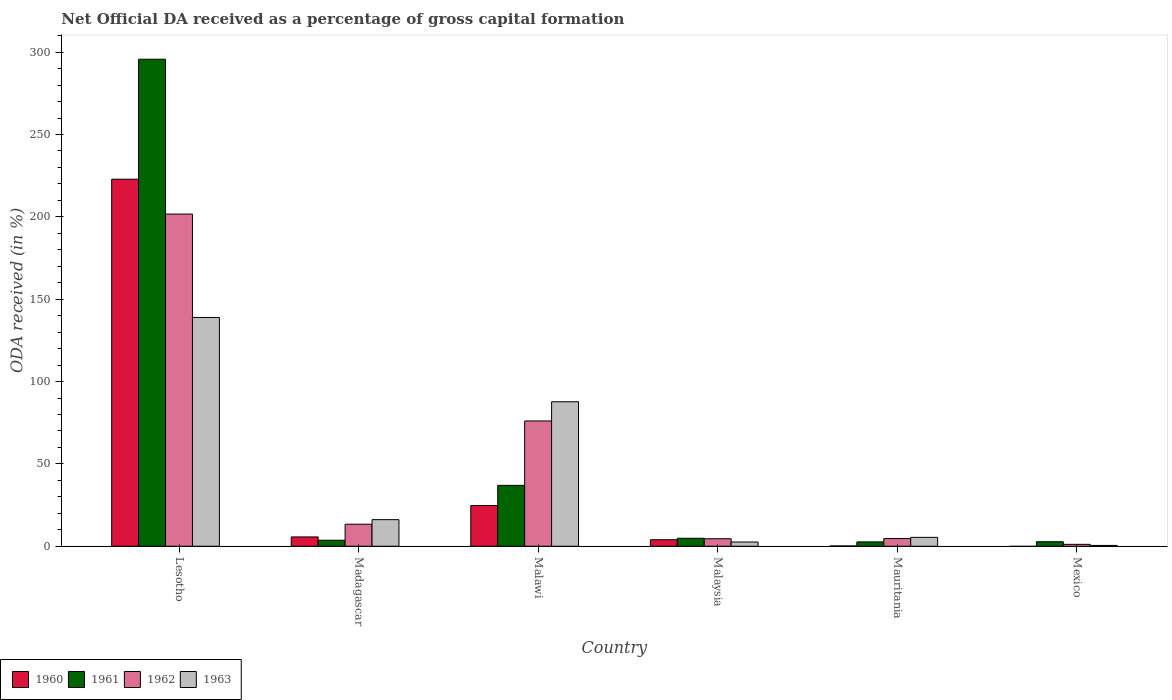How many different coloured bars are there?
Make the answer very short. 4. Are the number of bars per tick equal to the number of legend labels?
Give a very brief answer. No. What is the label of the 3rd group of bars from the left?
Your response must be concise. Malawi. In how many cases, is the number of bars for a given country not equal to the number of legend labels?
Provide a succinct answer. 1. What is the net ODA received in 1961 in Mexico?
Your answer should be very brief. 2.74. Across all countries, what is the maximum net ODA received in 1963?
Your answer should be very brief. 138.92. Across all countries, what is the minimum net ODA received in 1960?
Ensure brevity in your answer.  0. In which country was the net ODA received in 1961 maximum?
Give a very brief answer. Lesotho. What is the total net ODA received in 1962 in the graph?
Give a very brief answer. 301.54. What is the difference between the net ODA received in 1962 in Lesotho and that in Madagascar?
Your answer should be very brief. 188.32. What is the difference between the net ODA received in 1963 in Malawi and the net ODA received in 1960 in Lesotho?
Give a very brief answer. -135.12. What is the average net ODA received in 1962 per country?
Keep it short and to the point. 50.26. What is the difference between the net ODA received of/in 1963 and net ODA received of/in 1961 in Malawi?
Make the answer very short. 50.77. In how many countries, is the net ODA received in 1963 greater than 110 %?
Your answer should be compact. 1. What is the ratio of the net ODA received in 1963 in Mauritania to that in Mexico?
Provide a short and direct response. 10.77. Is the net ODA received in 1961 in Madagascar less than that in Mexico?
Provide a succinct answer. No. Is the difference between the net ODA received in 1963 in Madagascar and Mexico greater than the difference between the net ODA received in 1961 in Madagascar and Mexico?
Your answer should be very brief. Yes. What is the difference between the highest and the second highest net ODA received in 1961?
Your answer should be very brief. 32.13. What is the difference between the highest and the lowest net ODA received in 1963?
Keep it short and to the point. 138.41. Is it the case that in every country, the sum of the net ODA received in 1960 and net ODA received in 1961 is greater than the sum of net ODA received in 1963 and net ODA received in 1962?
Make the answer very short. No. Are all the bars in the graph horizontal?
Make the answer very short. No. What is the difference between two consecutive major ticks on the Y-axis?
Provide a succinct answer. 50. Does the graph contain any zero values?
Make the answer very short. Yes. Where does the legend appear in the graph?
Make the answer very short. Bottom left. How are the legend labels stacked?
Provide a succinct answer. Horizontal. What is the title of the graph?
Give a very brief answer. Net Official DA received as a percentage of gross capital formation. What is the label or title of the X-axis?
Your answer should be very brief. Country. What is the label or title of the Y-axis?
Make the answer very short. ODA received (in %). What is the ODA received (in %) of 1960 in Lesotho?
Ensure brevity in your answer.  222.86. What is the ODA received (in %) in 1961 in Lesotho?
Offer a very short reply. 295.71. What is the ODA received (in %) of 1962 in Lesotho?
Your answer should be very brief. 201.7. What is the ODA received (in %) of 1963 in Lesotho?
Offer a terse response. 138.92. What is the ODA received (in %) of 1960 in Madagascar?
Give a very brief answer. 5.66. What is the ODA received (in %) in 1961 in Madagascar?
Make the answer very short. 3.65. What is the ODA received (in %) of 1962 in Madagascar?
Your response must be concise. 13.38. What is the ODA received (in %) in 1963 in Madagascar?
Your response must be concise. 16.15. What is the ODA received (in %) of 1960 in Malawi?
Provide a short and direct response. 24.76. What is the ODA received (in %) of 1961 in Malawi?
Make the answer very short. 36.97. What is the ODA received (in %) of 1962 in Malawi?
Provide a short and direct response. 76.08. What is the ODA received (in %) of 1963 in Malawi?
Provide a short and direct response. 87.74. What is the ODA received (in %) in 1960 in Malaysia?
Keep it short and to the point. 3.95. What is the ODA received (in %) of 1961 in Malaysia?
Offer a terse response. 4.84. What is the ODA received (in %) of 1962 in Malaysia?
Make the answer very short. 4.56. What is the ODA received (in %) in 1963 in Malaysia?
Provide a short and direct response. 2.57. What is the ODA received (in %) of 1960 in Mauritania?
Your response must be concise. 0.19. What is the ODA received (in %) of 1961 in Mauritania?
Offer a very short reply. 2.65. What is the ODA received (in %) of 1962 in Mauritania?
Ensure brevity in your answer.  4.66. What is the ODA received (in %) of 1963 in Mauritania?
Keep it short and to the point. 5.4. What is the ODA received (in %) in 1961 in Mexico?
Keep it short and to the point. 2.74. What is the ODA received (in %) of 1962 in Mexico?
Give a very brief answer. 1.16. What is the ODA received (in %) of 1963 in Mexico?
Keep it short and to the point. 0.5. Across all countries, what is the maximum ODA received (in %) of 1960?
Your answer should be compact. 222.86. Across all countries, what is the maximum ODA received (in %) in 1961?
Offer a very short reply. 295.71. Across all countries, what is the maximum ODA received (in %) of 1962?
Offer a very short reply. 201.7. Across all countries, what is the maximum ODA received (in %) of 1963?
Your response must be concise. 138.92. Across all countries, what is the minimum ODA received (in %) of 1960?
Your response must be concise. 0. Across all countries, what is the minimum ODA received (in %) in 1961?
Make the answer very short. 2.65. Across all countries, what is the minimum ODA received (in %) in 1962?
Your response must be concise. 1.16. Across all countries, what is the minimum ODA received (in %) of 1963?
Keep it short and to the point. 0.5. What is the total ODA received (in %) in 1960 in the graph?
Make the answer very short. 257.42. What is the total ODA received (in %) in 1961 in the graph?
Ensure brevity in your answer.  346.57. What is the total ODA received (in %) of 1962 in the graph?
Keep it short and to the point. 301.54. What is the total ODA received (in %) in 1963 in the graph?
Provide a succinct answer. 251.28. What is the difference between the ODA received (in %) of 1960 in Lesotho and that in Madagascar?
Provide a succinct answer. 217.2. What is the difference between the ODA received (in %) in 1961 in Lesotho and that in Madagascar?
Provide a succinct answer. 292.06. What is the difference between the ODA received (in %) in 1962 in Lesotho and that in Madagascar?
Your response must be concise. 188.32. What is the difference between the ODA received (in %) of 1963 in Lesotho and that in Madagascar?
Your answer should be compact. 122.76. What is the difference between the ODA received (in %) of 1960 in Lesotho and that in Malawi?
Keep it short and to the point. 198.1. What is the difference between the ODA received (in %) of 1961 in Lesotho and that in Malawi?
Make the answer very short. 258.74. What is the difference between the ODA received (in %) in 1962 in Lesotho and that in Malawi?
Offer a very short reply. 125.62. What is the difference between the ODA received (in %) in 1963 in Lesotho and that in Malawi?
Provide a succinct answer. 51.18. What is the difference between the ODA received (in %) of 1960 in Lesotho and that in Malaysia?
Make the answer very short. 218.91. What is the difference between the ODA received (in %) in 1961 in Lesotho and that in Malaysia?
Offer a terse response. 290.87. What is the difference between the ODA received (in %) in 1962 in Lesotho and that in Malaysia?
Make the answer very short. 197.14. What is the difference between the ODA received (in %) in 1963 in Lesotho and that in Malaysia?
Ensure brevity in your answer.  136.35. What is the difference between the ODA received (in %) of 1960 in Lesotho and that in Mauritania?
Keep it short and to the point. 222.67. What is the difference between the ODA received (in %) of 1961 in Lesotho and that in Mauritania?
Keep it short and to the point. 293.07. What is the difference between the ODA received (in %) in 1962 in Lesotho and that in Mauritania?
Ensure brevity in your answer.  197.04. What is the difference between the ODA received (in %) of 1963 in Lesotho and that in Mauritania?
Offer a very short reply. 133.51. What is the difference between the ODA received (in %) of 1961 in Lesotho and that in Mexico?
Provide a short and direct response. 292.98. What is the difference between the ODA received (in %) of 1962 in Lesotho and that in Mexico?
Provide a succinct answer. 200.54. What is the difference between the ODA received (in %) of 1963 in Lesotho and that in Mexico?
Give a very brief answer. 138.41. What is the difference between the ODA received (in %) of 1960 in Madagascar and that in Malawi?
Ensure brevity in your answer.  -19.11. What is the difference between the ODA received (in %) in 1961 in Madagascar and that in Malawi?
Offer a very short reply. -33.32. What is the difference between the ODA received (in %) in 1962 in Madagascar and that in Malawi?
Your answer should be compact. -62.7. What is the difference between the ODA received (in %) in 1963 in Madagascar and that in Malawi?
Ensure brevity in your answer.  -71.59. What is the difference between the ODA received (in %) of 1960 in Madagascar and that in Malaysia?
Keep it short and to the point. 1.7. What is the difference between the ODA received (in %) in 1961 in Madagascar and that in Malaysia?
Keep it short and to the point. -1.19. What is the difference between the ODA received (in %) in 1962 in Madagascar and that in Malaysia?
Keep it short and to the point. 8.82. What is the difference between the ODA received (in %) of 1963 in Madagascar and that in Malaysia?
Your answer should be very brief. 13.59. What is the difference between the ODA received (in %) of 1960 in Madagascar and that in Mauritania?
Give a very brief answer. 5.46. What is the difference between the ODA received (in %) of 1962 in Madagascar and that in Mauritania?
Provide a succinct answer. 8.72. What is the difference between the ODA received (in %) in 1963 in Madagascar and that in Mauritania?
Keep it short and to the point. 10.75. What is the difference between the ODA received (in %) of 1962 in Madagascar and that in Mexico?
Offer a terse response. 12.22. What is the difference between the ODA received (in %) of 1963 in Madagascar and that in Mexico?
Ensure brevity in your answer.  15.65. What is the difference between the ODA received (in %) of 1960 in Malawi and that in Malaysia?
Your response must be concise. 20.81. What is the difference between the ODA received (in %) of 1961 in Malawi and that in Malaysia?
Offer a terse response. 32.13. What is the difference between the ODA received (in %) in 1962 in Malawi and that in Malaysia?
Provide a succinct answer. 71.52. What is the difference between the ODA received (in %) in 1963 in Malawi and that in Malaysia?
Your answer should be compact. 85.17. What is the difference between the ODA received (in %) of 1960 in Malawi and that in Mauritania?
Offer a terse response. 24.57. What is the difference between the ODA received (in %) in 1961 in Malawi and that in Mauritania?
Keep it short and to the point. 34.32. What is the difference between the ODA received (in %) in 1962 in Malawi and that in Mauritania?
Provide a succinct answer. 71.42. What is the difference between the ODA received (in %) of 1963 in Malawi and that in Mauritania?
Offer a very short reply. 82.34. What is the difference between the ODA received (in %) of 1961 in Malawi and that in Mexico?
Your response must be concise. 34.23. What is the difference between the ODA received (in %) of 1962 in Malawi and that in Mexico?
Provide a short and direct response. 74.92. What is the difference between the ODA received (in %) of 1963 in Malawi and that in Mexico?
Provide a short and direct response. 87.24. What is the difference between the ODA received (in %) of 1960 in Malaysia and that in Mauritania?
Your answer should be compact. 3.76. What is the difference between the ODA received (in %) in 1961 in Malaysia and that in Mauritania?
Provide a succinct answer. 2.2. What is the difference between the ODA received (in %) in 1962 in Malaysia and that in Mauritania?
Offer a terse response. -0.1. What is the difference between the ODA received (in %) of 1963 in Malaysia and that in Mauritania?
Offer a very short reply. -2.83. What is the difference between the ODA received (in %) in 1961 in Malaysia and that in Mexico?
Make the answer very short. 2.11. What is the difference between the ODA received (in %) of 1962 in Malaysia and that in Mexico?
Make the answer very short. 3.4. What is the difference between the ODA received (in %) of 1963 in Malaysia and that in Mexico?
Your response must be concise. 2.07. What is the difference between the ODA received (in %) in 1961 in Mauritania and that in Mexico?
Your answer should be compact. -0.09. What is the difference between the ODA received (in %) of 1962 in Mauritania and that in Mexico?
Provide a succinct answer. 3.51. What is the difference between the ODA received (in %) of 1963 in Mauritania and that in Mexico?
Your answer should be compact. 4.9. What is the difference between the ODA received (in %) of 1960 in Lesotho and the ODA received (in %) of 1961 in Madagascar?
Provide a short and direct response. 219.21. What is the difference between the ODA received (in %) in 1960 in Lesotho and the ODA received (in %) in 1962 in Madagascar?
Your response must be concise. 209.48. What is the difference between the ODA received (in %) of 1960 in Lesotho and the ODA received (in %) of 1963 in Madagascar?
Your answer should be compact. 206.7. What is the difference between the ODA received (in %) in 1961 in Lesotho and the ODA received (in %) in 1962 in Madagascar?
Your response must be concise. 282.33. What is the difference between the ODA received (in %) of 1961 in Lesotho and the ODA received (in %) of 1963 in Madagascar?
Ensure brevity in your answer.  279.56. What is the difference between the ODA received (in %) in 1962 in Lesotho and the ODA received (in %) in 1963 in Madagascar?
Offer a very short reply. 185.55. What is the difference between the ODA received (in %) of 1960 in Lesotho and the ODA received (in %) of 1961 in Malawi?
Keep it short and to the point. 185.89. What is the difference between the ODA received (in %) in 1960 in Lesotho and the ODA received (in %) in 1962 in Malawi?
Offer a terse response. 146.78. What is the difference between the ODA received (in %) of 1960 in Lesotho and the ODA received (in %) of 1963 in Malawi?
Your answer should be very brief. 135.12. What is the difference between the ODA received (in %) of 1961 in Lesotho and the ODA received (in %) of 1962 in Malawi?
Ensure brevity in your answer.  219.63. What is the difference between the ODA received (in %) of 1961 in Lesotho and the ODA received (in %) of 1963 in Malawi?
Your response must be concise. 207.97. What is the difference between the ODA received (in %) of 1962 in Lesotho and the ODA received (in %) of 1963 in Malawi?
Ensure brevity in your answer.  113.96. What is the difference between the ODA received (in %) of 1960 in Lesotho and the ODA received (in %) of 1961 in Malaysia?
Give a very brief answer. 218.01. What is the difference between the ODA received (in %) in 1960 in Lesotho and the ODA received (in %) in 1962 in Malaysia?
Ensure brevity in your answer.  218.3. What is the difference between the ODA received (in %) of 1960 in Lesotho and the ODA received (in %) of 1963 in Malaysia?
Give a very brief answer. 220.29. What is the difference between the ODA received (in %) of 1961 in Lesotho and the ODA received (in %) of 1962 in Malaysia?
Your answer should be compact. 291.15. What is the difference between the ODA received (in %) in 1961 in Lesotho and the ODA received (in %) in 1963 in Malaysia?
Your response must be concise. 293.15. What is the difference between the ODA received (in %) in 1962 in Lesotho and the ODA received (in %) in 1963 in Malaysia?
Keep it short and to the point. 199.13. What is the difference between the ODA received (in %) in 1960 in Lesotho and the ODA received (in %) in 1961 in Mauritania?
Your answer should be compact. 220.21. What is the difference between the ODA received (in %) in 1960 in Lesotho and the ODA received (in %) in 1962 in Mauritania?
Provide a short and direct response. 218.19. What is the difference between the ODA received (in %) of 1960 in Lesotho and the ODA received (in %) of 1963 in Mauritania?
Provide a succinct answer. 217.45. What is the difference between the ODA received (in %) of 1961 in Lesotho and the ODA received (in %) of 1962 in Mauritania?
Provide a succinct answer. 291.05. What is the difference between the ODA received (in %) of 1961 in Lesotho and the ODA received (in %) of 1963 in Mauritania?
Your answer should be compact. 290.31. What is the difference between the ODA received (in %) of 1962 in Lesotho and the ODA received (in %) of 1963 in Mauritania?
Give a very brief answer. 196.3. What is the difference between the ODA received (in %) in 1960 in Lesotho and the ODA received (in %) in 1961 in Mexico?
Your response must be concise. 220.12. What is the difference between the ODA received (in %) of 1960 in Lesotho and the ODA received (in %) of 1962 in Mexico?
Ensure brevity in your answer.  221.7. What is the difference between the ODA received (in %) of 1960 in Lesotho and the ODA received (in %) of 1963 in Mexico?
Keep it short and to the point. 222.36. What is the difference between the ODA received (in %) of 1961 in Lesotho and the ODA received (in %) of 1962 in Mexico?
Your answer should be compact. 294.56. What is the difference between the ODA received (in %) in 1961 in Lesotho and the ODA received (in %) in 1963 in Mexico?
Offer a very short reply. 295.21. What is the difference between the ODA received (in %) of 1962 in Lesotho and the ODA received (in %) of 1963 in Mexico?
Offer a terse response. 201.2. What is the difference between the ODA received (in %) in 1960 in Madagascar and the ODA received (in %) in 1961 in Malawi?
Your answer should be very brief. -31.32. What is the difference between the ODA received (in %) of 1960 in Madagascar and the ODA received (in %) of 1962 in Malawi?
Your answer should be very brief. -70.43. What is the difference between the ODA received (in %) of 1960 in Madagascar and the ODA received (in %) of 1963 in Malawi?
Make the answer very short. -82.08. What is the difference between the ODA received (in %) of 1961 in Madagascar and the ODA received (in %) of 1962 in Malawi?
Keep it short and to the point. -72.43. What is the difference between the ODA received (in %) of 1961 in Madagascar and the ODA received (in %) of 1963 in Malawi?
Ensure brevity in your answer.  -84.09. What is the difference between the ODA received (in %) of 1962 in Madagascar and the ODA received (in %) of 1963 in Malawi?
Your response must be concise. -74.36. What is the difference between the ODA received (in %) of 1960 in Madagascar and the ODA received (in %) of 1961 in Malaysia?
Ensure brevity in your answer.  0.81. What is the difference between the ODA received (in %) of 1960 in Madagascar and the ODA received (in %) of 1962 in Malaysia?
Keep it short and to the point. 1.09. What is the difference between the ODA received (in %) in 1960 in Madagascar and the ODA received (in %) in 1963 in Malaysia?
Provide a succinct answer. 3.09. What is the difference between the ODA received (in %) in 1961 in Madagascar and the ODA received (in %) in 1962 in Malaysia?
Provide a succinct answer. -0.91. What is the difference between the ODA received (in %) in 1961 in Madagascar and the ODA received (in %) in 1963 in Malaysia?
Provide a short and direct response. 1.08. What is the difference between the ODA received (in %) in 1962 in Madagascar and the ODA received (in %) in 1963 in Malaysia?
Your answer should be very brief. 10.81. What is the difference between the ODA received (in %) in 1960 in Madagascar and the ODA received (in %) in 1961 in Mauritania?
Your answer should be compact. 3.01. What is the difference between the ODA received (in %) in 1960 in Madagascar and the ODA received (in %) in 1963 in Mauritania?
Keep it short and to the point. 0.25. What is the difference between the ODA received (in %) of 1961 in Madagascar and the ODA received (in %) of 1962 in Mauritania?
Keep it short and to the point. -1.01. What is the difference between the ODA received (in %) of 1961 in Madagascar and the ODA received (in %) of 1963 in Mauritania?
Provide a short and direct response. -1.75. What is the difference between the ODA received (in %) in 1962 in Madagascar and the ODA received (in %) in 1963 in Mauritania?
Your response must be concise. 7.98. What is the difference between the ODA received (in %) of 1960 in Madagascar and the ODA received (in %) of 1961 in Mexico?
Make the answer very short. 2.92. What is the difference between the ODA received (in %) of 1960 in Madagascar and the ODA received (in %) of 1962 in Mexico?
Provide a succinct answer. 4.5. What is the difference between the ODA received (in %) of 1960 in Madagascar and the ODA received (in %) of 1963 in Mexico?
Keep it short and to the point. 5.15. What is the difference between the ODA received (in %) in 1961 in Madagascar and the ODA received (in %) in 1962 in Mexico?
Give a very brief answer. 2.49. What is the difference between the ODA received (in %) in 1961 in Madagascar and the ODA received (in %) in 1963 in Mexico?
Offer a very short reply. 3.15. What is the difference between the ODA received (in %) of 1962 in Madagascar and the ODA received (in %) of 1963 in Mexico?
Offer a very short reply. 12.88. What is the difference between the ODA received (in %) in 1960 in Malawi and the ODA received (in %) in 1961 in Malaysia?
Your answer should be compact. 19.92. What is the difference between the ODA received (in %) of 1960 in Malawi and the ODA received (in %) of 1962 in Malaysia?
Your answer should be very brief. 20.2. What is the difference between the ODA received (in %) in 1960 in Malawi and the ODA received (in %) in 1963 in Malaysia?
Offer a terse response. 22.19. What is the difference between the ODA received (in %) of 1961 in Malawi and the ODA received (in %) of 1962 in Malaysia?
Your answer should be very brief. 32.41. What is the difference between the ODA received (in %) of 1961 in Malawi and the ODA received (in %) of 1963 in Malaysia?
Give a very brief answer. 34.4. What is the difference between the ODA received (in %) in 1962 in Malawi and the ODA received (in %) in 1963 in Malaysia?
Ensure brevity in your answer.  73.51. What is the difference between the ODA received (in %) of 1960 in Malawi and the ODA received (in %) of 1961 in Mauritania?
Give a very brief answer. 22.11. What is the difference between the ODA received (in %) in 1960 in Malawi and the ODA received (in %) in 1962 in Mauritania?
Offer a terse response. 20.1. What is the difference between the ODA received (in %) of 1960 in Malawi and the ODA received (in %) of 1963 in Mauritania?
Keep it short and to the point. 19.36. What is the difference between the ODA received (in %) of 1961 in Malawi and the ODA received (in %) of 1962 in Mauritania?
Give a very brief answer. 32.31. What is the difference between the ODA received (in %) in 1961 in Malawi and the ODA received (in %) in 1963 in Mauritania?
Ensure brevity in your answer.  31.57. What is the difference between the ODA received (in %) in 1962 in Malawi and the ODA received (in %) in 1963 in Mauritania?
Your answer should be very brief. 70.68. What is the difference between the ODA received (in %) of 1960 in Malawi and the ODA received (in %) of 1961 in Mexico?
Make the answer very short. 22.02. What is the difference between the ODA received (in %) of 1960 in Malawi and the ODA received (in %) of 1962 in Mexico?
Give a very brief answer. 23.6. What is the difference between the ODA received (in %) of 1960 in Malawi and the ODA received (in %) of 1963 in Mexico?
Make the answer very short. 24.26. What is the difference between the ODA received (in %) of 1961 in Malawi and the ODA received (in %) of 1962 in Mexico?
Your answer should be compact. 35.82. What is the difference between the ODA received (in %) of 1961 in Malawi and the ODA received (in %) of 1963 in Mexico?
Provide a succinct answer. 36.47. What is the difference between the ODA received (in %) of 1962 in Malawi and the ODA received (in %) of 1963 in Mexico?
Give a very brief answer. 75.58. What is the difference between the ODA received (in %) in 1960 in Malaysia and the ODA received (in %) in 1961 in Mauritania?
Ensure brevity in your answer.  1.3. What is the difference between the ODA received (in %) of 1960 in Malaysia and the ODA received (in %) of 1962 in Mauritania?
Ensure brevity in your answer.  -0.71. What is the difference between the ODA received (in %) of 1960 in Malaysia and the ODA received (in %) of 1963 in Mauritania?
Ensure brevity in your answer.  -1.45. What is the difference between the ODA received (in %) in 1961 in Malaysia and the ODA received (in %) in 1962 in Mauritania?
Give a very brief answer. 0.18. What is the difference between the ODA received (in %) in 1961 in Malaysia and the ODA received (in %) in 1963 in Mauritania?
Keep it short and to the point. -0.56. What is the difference between the ODA received (in %) of 1962 in Malaysia and the ODA received (in %) of 1963 in Mauritania?
Provide a succinct answer. -0.84. What is the difference between the ODA received (in %) in 1960 in Malaysia and the ODA received (in %) in 1961 in Mexico?
Your response must be concise. 1.21. What is the difference between the ODA received (in %) of 1960 in Malaysia and the ODA received (in %) of 1962 in Mexico?
Keep it short and to the point. 2.79. What is the difference between the ODA received (in %) in 1960 in Malaysia and the ODA received (in %) in 1963 in Mexico?
Offer a very short reply. 3.45. What is the difference between the ODA received (in %) in 1961 in Malaysia and the ODA received (in %) in 1962 in Mexico?
Your answer should be very brief. 3.69. What is the difference between the ODA received (in %) of 1961 in Malaysia and the ODA received (in %) of 1963 in Mexico?
Provide a succinct answer. 4.34. What is the difference between the ODA received (in %) in 1962 in Malaysia and the ODA received (in %) in 1963 in Mexico?
Offer a terse response. 4.06. What is the difference between the ODA received (in %) of 1960 in Mauritania and the ODA received (in %) of 1961 in Mexico?
Your answer should be compact. -2.55. What is the difference between the ODA received (in %) of 1960 in Mauritania and the ODA received (in %) of 1962 in Mexico?
Offer a terse response. -0.97. What is the difference between the ODA received (in %) of 1960 in Mauritania and the ODA received (in %) of 1963 in Mexico?
Offer a very short reply. -0.31. What is the difference between the ODA received (in %) of 1961 in Mauritania and the ODA received (in %) of 1962 in Mexico?
Make the answer very short. 1.49. What is the difference between the ODA received (in %) of 1961 in Mauritania and the ODA received (in %) of 1963 in Mexico?
Keep it short and to the point. 2.15. What is the difference between the ODA received (in %) of 1962 in Mauritania and the ODA received (in %) of 1963 in Mexico?
Provide a short and direct response. 4.16. What is the average ODA received (in %) of 1960 per country?
Your response must be concise. 42.9. What is the average ODA received (in %) in 1961 per country?
Keep it short and to the point. 57.76. What is the average ODA received (in %) of 1962 per country?
Your response must be concise. 50.26. What is the average ODA received (in %) of 1963 per country?
Your answer should be compact. 41.88. What is the difference between the ODA received (in %) in 1960 and ODA received (in %) in 1961 in Lesotho?
Your answer should be very brief. -72.86. What is the difference between the ODA received (in %) in 1960 and ODA received (in %) in 1962 in Lesotho?
Offer a terse response. 21.16. What is the difference between the ODA received (in %) of 1960 and ODA received (in %) of 1963 in Lesotho?
Give a very brief answer. 83.94. What is the difference between the ODA received (in %) of 1961 and ODA received (in %) of 1962 in Lesotho?
Your response must be concise. 94.01. What is the difference between the ODA received (in %) of 1961 and ODA received (in %) of 1963 in Lesotho?
Give a very brief answer. 156.8. What is the difference between the ODA received (in %) in 1962 and ODA received (in %) in 1963 in Lesotho?
Give a very brief answer. 62.78. What is the difference between the ODA received (in %) of 1960 and ODA received (in %) of 1961 in Madagascar?
Give a very brief answer. 2. What is the difference between the ODA received (in %) in 1960 and ODA received (in %) in 1962 in Madagascar?
Offer a very short reply. -7.72. What is the difference between the ODA received (in %) in 1960 and ODA received (in %) in 1963 in Madagascar?
Keep it short and to the point. -10.5. What is the difference between the ODA received (in %) in 1961 and ODA received (in %) in 1962 in Madagascar?
Give a very brief answer. -9.73. What is the difference between the ODA received (in %) of 1961 and ODA received (in %) of 1963 in Madagascar?
Provide a short and direct response. -12.5. What is the difference between the ODA received (in %) of 1962 and ODA received (in %) of 1963 in Madagascar?
Offer a very short reply. -2.77. What is the difference between the ODA received (in %) of 1960 and ODA received (in %) of 1961 in Malawi?
Provide a succinct answer. -12.21. What is the difference between the ODA received (in %) of 1960 and ODA received (in %) of 1962 in Malawi?
Give a very brief answer. -51.32. What is the difference between the ODA received (in %) in 1960 and ODA received (in %) in 1963 in Malawi?
Provide a succinct answer. -62.98. What is the difference between the ODA received (in %) of 1961 and ODA received (in %) of 1962 in Malawi?
Offer a very short reply. -39.11. What is the difference between the ODA received (in %) in 1961 and ODA received (in %) in 1963 in Malawi?
Offer a terse response. -50.77. What is the difference between the ODA received (in %) in 1962 and ODA received (in %) in 1963 in Malawi?
Provide a short and direct response. -11.66. What is the difference between the ODA received (in %) in 1960 and ODA received (in %) in 1961 in Malaysia?
Make the answer very short. -0.89. What is the difference between the ODA received (in %) of 1960 and ODA received (in %) of 1962 in Malaysia?
Keep it short and to the point. -0.61. What is the difference between the ODA received (in %) in 1960 and ODA received (in %) in 1963 in Malaysia?
Provide a short and direct response. 1.38. What is the difference between the ODA received (in %) in 1961 and ODA received (in %) in 1962 in Malaysia?
Keep it short and to the point. 0.28. What is the difference between the ODA received (in %) of 1961 and ODA received (in %) of 1963 in Malaysia?
Offer a very short reply. 2.28. What is the difference between the ODA received (in %) in 1962 and ODA received (in %) in 1963 in Malaysia?
Provide a succinct answer. 1.99. What is the difference between the ODA received (in %) of 1960 and ODA received (in %) of 1961 in Mauritania?
Ensure brevity in your answer.  -2.46. What is the difference between the ODA received (in %) of 1960 and ODA received (in %) of 1962 in Mauritania?
Your answer should be compact. -4.47. What is the difference between the ODA received (in %) of 1960 and ODA received (in %) of 1963 in Mauritania?
Your answer should be very brief. -5.21. What is the difference between the ODA received (in %) in 1961 and ODA received (in %) in 1962 in Mauritania?
Make the answer very short. -2.02. What is the difference between the ODA received (in %) of 1961 and ODA received (in %) of 1963 in Mauritania?
Provide a succinct answer. -2.75. What is the difference between the ODA received (in %) in 1962 and ODA received (in %) in 1963 in Mauritania?
Offer a terse response. -0.74. What is the difference between the ODA received (in %) of 1961 and ODA received (in %) of 1962 in Mexico?
Make the answer very short. 1.58. What is the difference between the ODA received (in %) in 1961 and ODA received (in %) in 1963 in Mexico?
Offer a very short reply. 2.24. What is the difference between the ODA received (in %) in 1962 and ODA received (in %) in 1963 in Mexico?
Your answer should be compact. 0.66. What is the ratio of the ODA received (in %) of 1960 in Lesotho to that in Madagascar?
Keep it short and to the point. 39.4. What is the ratio of the ODA received (in %) of 1961 in Lesotho to that in Madagascar?
Provide a short and direct response. 80.97. What is the ratio of the ODA received (in %) of 1962 in Lesotho to that in Madagascar?
Make the answer very short. 15.07. What is the ratio of the ODA received (in %) of 1963 in Lesotho to that in Madagascar?
Ensure brevity in your answer.  8.6. What is the ratio of the ODA received (in %) in 1960 in Lesotho to that in Malawi?
Provide a succinct answer. 9. What is the ratio of the ODA received (in %) in 1961 in Lesotho to that in Malawi?
Give a very brief answer. 8. What is the ratio of the ODA received (in %) of 1962 in Lesotho to that in Malawi?
Offer a terse response. 2.65. What is the ratio of the ODA received (in %) of 1963 in Lesotho to that in Malawi?
Make the answer very short. 1.58. What is the ratio of the ODA received (in %) of 1960 in Lesotho to that in Malaysia?
Provide a short and direct response. 56.41. What is the ratio of the ODA received (in %) of 1961 in Lesotho to that in Malaysia?
Make the answer very short. 61.04. What is the ratio of the ODA received (in %) in 1962 in Lesotho to that in Malaysia?
Make the answer very short. 44.23. What is the ratio of the ODA received (in %) in 1963 in Lesotho to that in Malaysia?
Ensure brevity in your answer.  54.07. What is the ratio of the ODA received (in %) of 1960 in Lesotho to that in Mauritania?
Provide a short and direct response. 1167.54. What is the ratio of the ODA received (in %) of 1961 in Lesotho to that in Mauritania?
Your answer should be compact. 111.63. What is the ratio of the ODA received (in %) of 1962 in Lesotho to that in Mauritania?
Your answer should be very brief. 43.24. What is the ratio of the ODA received (in %) of 1963 in Lesotho to that in Mauritania?
Make the answer very short. 25.71. What is the ratio of the ODA received (in %) in 1961 in Lesotho to that in Mexico?
Give a very brief answer. 107.96. What is the ratio of the ODA received (in %) of 1962 in Lesotho to that in Mexico?
Your answer should be compact. 174.32. What is the ratio of the ODA received (in %) in 1963 in Lesotho to that in Mexico?
Provide a short and direct response. 276.96. What is the ratio of the ODA received (in %) in 1960 in Madagascar to that in Malawi?
Give a very brief answer. 0.23. What is the ratio of the ODA received (in %) of 1961 in Madagascar to that in Malawi?
Your answer should be compact. 0.1. What is the ratio of the ODA received (in %) in 1962 in Madagascar to that in Malawi?
Keep it short and to the point. 0.18. What is the ratio of the ODA received (in %) in 1963 in Madagascar to that in Malawi?
Your response must be concise. 0.18. What is the ratio of the ODA received (in %) of 1960 in Madagascar to that in Malaysia?
Give a very brief answer. 1.43. What is the ratio of the ODA received (in %) in 1961 in Madagascar to that in Malaysia?
Provide a succinct answer. 0.75. What is the ratio of the ODA received (in %) in 1962 in Madagascar to that in Malaysia?
Your answer should be compact. 2.93. What is the ratio of the ODA received (in %) in 1963 in Madagascar to that in Malaysia?
Provide a short and direct response. 6.29. What is the ratio of the ODA received (in %) in 1960 in Madagascar to that in Mauritania?
Provide a short and direct response. 29.63. What is the ratio of the ODA received (in %) of 1961 in Madagascar to that in Mauritania?
Ensure brevity in your answer.  1.38. What is the ratio of the ODA received (in %) of 1962 in Madagascar to that in Mauritania?
Offer a very short reply. 2.87. What is the ratio of the ODA received (in %) in 1963 in Madagascar to that in Mauritania?
Offer a terse response. 2.99. What is the ratio of the ODA received (in %) in 1961 in Madagascar to that in Mexico?
Your response must be concise. 1.33. What is the ratio of the ODA received (in %) in 1962 in Madagascar to that in Mexico?
Provide a short and direct response. 11.56. What is the ratio of the ODA received (in %) in 1963 in Madagascar to that in Mexico?
Your response must be concise. 32.21. What is the ratio of the ODA received (in %) of 1960 in Malawi to that in Malaysia?
Your response must be concise. 6.27. What is the ratio of the ODA received (in %) of 1961 in Malawi to that in Malaysia?
Offer a very short reply. 7.63. What is the ratio of the ODA received (in %) of 1962 in Malawi to that in Malaysia?
Ensure brevity in your answer.  16.68. What is the ratio of the ODA received (in %) of 1963 in Malawi to that in Malaysia?
Give a very brief answer. 34.15. What is the ratio of the ODA received (in %) in 1960 in Malawi to that in Mauritania?
Offer a very short reply. 129.73. What is the ratio of the ODA received (in %) in 1961 in Malawi to that in Mauritania?
Offer a very short reply. 13.96. What is the ratio of the ODA received (in %) of 1962 in Malawi to that in Mauritania?
Ensure brevity in your answer.  16.31. What is the ratio of the ODA received (in %) of 1963 in Malawi to that in Mauritania?
Your answer should be compact. 16.24. What is the ratio of the ODA received (in %) of 1961 in Malawi to that in Mexico?
Your response must be concise. 13.5. What is the ratio of the ODA received (in %) in 1962 in Malawi to that in Mexico?
Provide a succinct answer. 65.75. What is the ratio of the ODA received (in %) in 1963 in Malawi to that in Mexico?
Offer a terse response. 174.93. What is the ratio of the ODA received (in %) of 1960 in Malaysia to that in Mauritania?
Your answer should be very brief. 20.7. What is the ratio of the ODA received (in %) in 1961 in Malaysia to that in Mauritania?
Offer a very short reply. 1.83. What is the ratio of the ODA received (in %) of 1962 in Malaysia to that in Mauritania?
Give a very brief answer. 0.98. What is the ratio of the ODA received (in %) in 1963 in Malaysia to that in Mauritania?
Provide a short and direct response. 0.48. What is the ratio of the ODA received (in %) in 1961 in Malaysia to that in Mexico?
Offer a terse response. 1.77. What is the ratio of the ODA received (in %) of 1962 in Malaysia to that in Mexico?
Give a very brief answer. 3.94. What is the ratio of the ODA received (in %) of 1963 in Malaysia to that in Mexico?
Your answer should be compact. 5.12. What is the ratio of the ODA received (in %) of 1961 in Mauritania to that in Mexico?
Your answer should be compact. 0.97. What is the ratio of the ODA received (in %) of 1962 in Mauritania to that in Mexico?
Keep it short and to the point. 4.03. What is the ratio of the ODA received (in %) of 1963 in Mauritania to that in Mexico?
Provide a short and direct response. 10.77. What is the difference between the highest and the second highest ODA received (in %) in 1960?
Make the answer very short. 198.1. What is the difference between the highest and the second highest ODA received (in %) of 1961?
Your answer should be very brief. 258.74. What is the difference between the highest and the second highest ODA received (in %) of 1962?
Keep it short and to the point. 125.62. What is the difference between the highest and the second highest ODA received (in %) of 1963?
Provide a succinct answer. 51.18. What is the difference between the highest and the lowest ODA received (in %) in 1960?
Make the answer very short. 222.86. What is the difference between the highest and the lowest ODA received (in %) in 1961?
Provide a short and direct response. 293.07. What is the difference between the highest and the lowest ODA received (in %) in 1962?
Offer a very short reply. 200.54. What is the difference between the highest and the lowest ODA received (in %) in 1963?
Give a very brief answer. 138.41. 